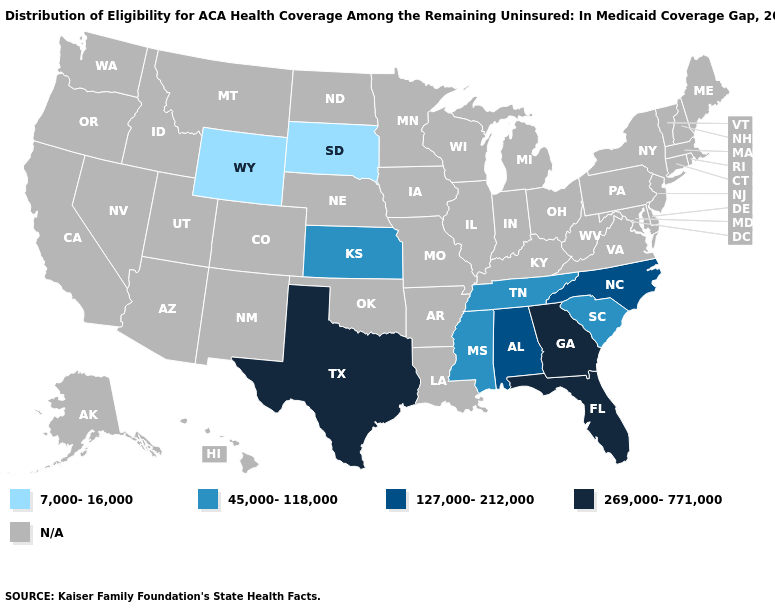Does Texas have the highest value in the USA?
Short answer required. Yes. What is the value of Maine?
Give a very brief answer. N/A. What is the value of Iowa?
Write a very short answer. N/A. What is the value of Nevada?
Answer briefly. N/A. Which states have the lowest value in the USA?
Concise answer only. South Dakota, Wyoming. Name the states that have a value in the range 269,000-771,000?
Quick response, please. Florida, Georgia, Texas. Name the states that have a value in the range 45,000-118,000?
Short answer required. Kansas, Mississippi, South Carolina, Tennessee. What is the lowest value in the South?
Be succinct. 45,000-118,000. Which states hav the highest value in the West?
Concise answer only. Wyoming. Which states have the lowest value in the South?
Concise answer only. Mississippi, South Carolina, Tennessee. Which states have the lowest value in the South?
Quick response, please. Mississippi, South Carolina, Tennessee. What is the highest value in the West ?
Be succinct. 7,000-16,000. Name the states that have a value in the range 45,000-118,000?
Keep it brief. Kansas, Mississippi, South Carolina, Tennessee. What is the value of Connecticut?
Answer briefly. N/A. 